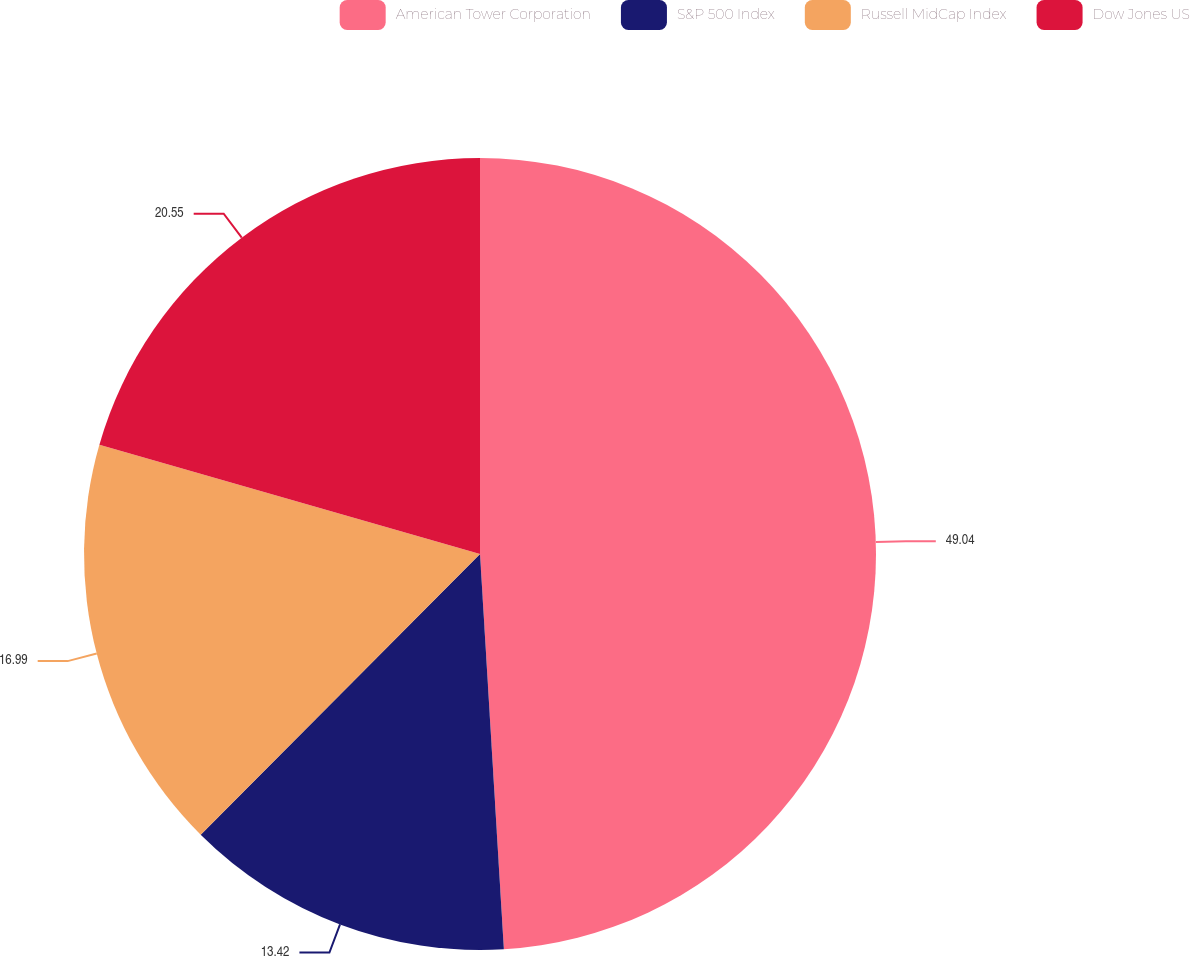Convert chart to OTSL. <chart><loc_0><loc_0><loc_500><loc_500><pie_chart><fcel>American Tower Corporation<fcel>S&P 500 Index<fcel>Russell MidCap Index<fcel>Dow Jones US<nl><fcel>49.04%<fcel>13.42%<fcel>16.99%<fcel>20.55%<nl></chart> 